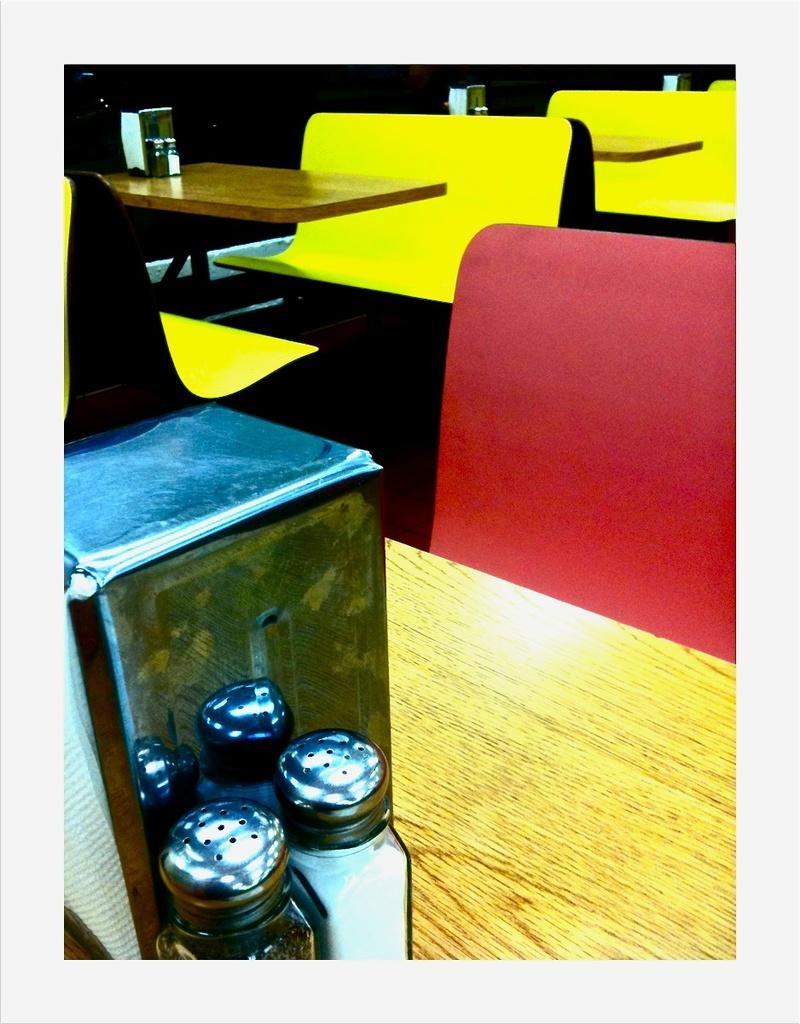Can you describe this image briefly? In this image I can see at the bottom there are ingredient glass jars. At the top there are sitting benches, in the middle there are dining tables. 